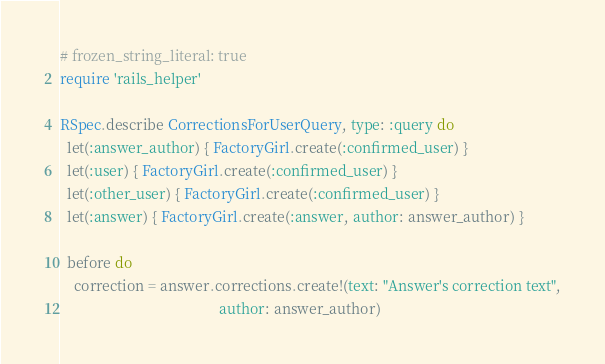<code> <loc_0><loc_0><loc_500><loc_500><_Ruby_># frozen_string_literal: true
require 'rails_helper'

RSpec.describe CorrectionsForUserQuery, type: :query do
  let(:answer_author) { FactoryGirl.create(:confirmed_user) }
  let(:user) { FactoryGirl.create(:confirmed_user) }
  let(:other_user) { FactoryGirl.create(:confirmed_user) }
  let(:answer) { FactoryGirl.create(:answer, author: answer_author) }

  before do
    correction = answer.corrections.create!(text: "Answer's correction text",
                                            author: answer_author)</code> 